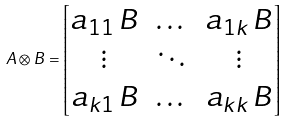<formula> <loc_0><loc_0><loc_500><loc_500>A \otimes B = \begin{bmatrix} a _ { 1 1 } \, B & \dots & a _ { 1 k } \, B \\ \vdots & \ddots & \vdots \\ a _ { k 1 } \, B & \dots & a _ { k k } \, B \end{bmatrix}</formula> 